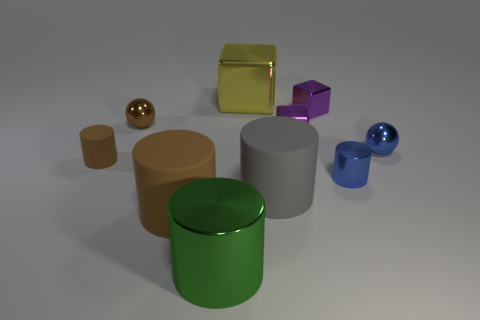Can you tell me which objects in the image are reflective? Certainly. The golden sphere, golden cube, purple cube, and both of the blue spheres exhibit reflective surfaces, as indicated by the visible highlights and mirrored environment on their exteriors. 